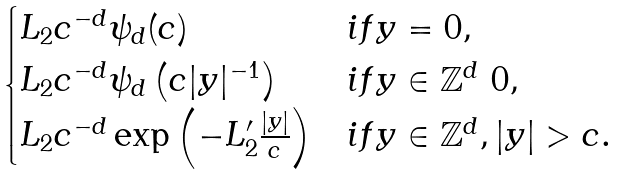<formula> <loc_0><loc_0><loc_500><loc_500>\begin{cases} L _ { 2 } c ^ { - d } \psi _ { d } ( c ) & i f y = 0 , \\ L _ { 2 } c ^ { - d } \psi _ { d } \left ( c | y | ^ { - 1 } \right ) & i f y \in \mathbb { Z } ^ { d } \ 0 , \\ L _ { 2 } c ^ { - d } \exp \left ( - L _ { 2 } ^ { \prime } \frac { | y | } { c } \right ) & i f y \in \mathbb { Z } ^ { d } , | y | > c . \end{cases}</formula> 